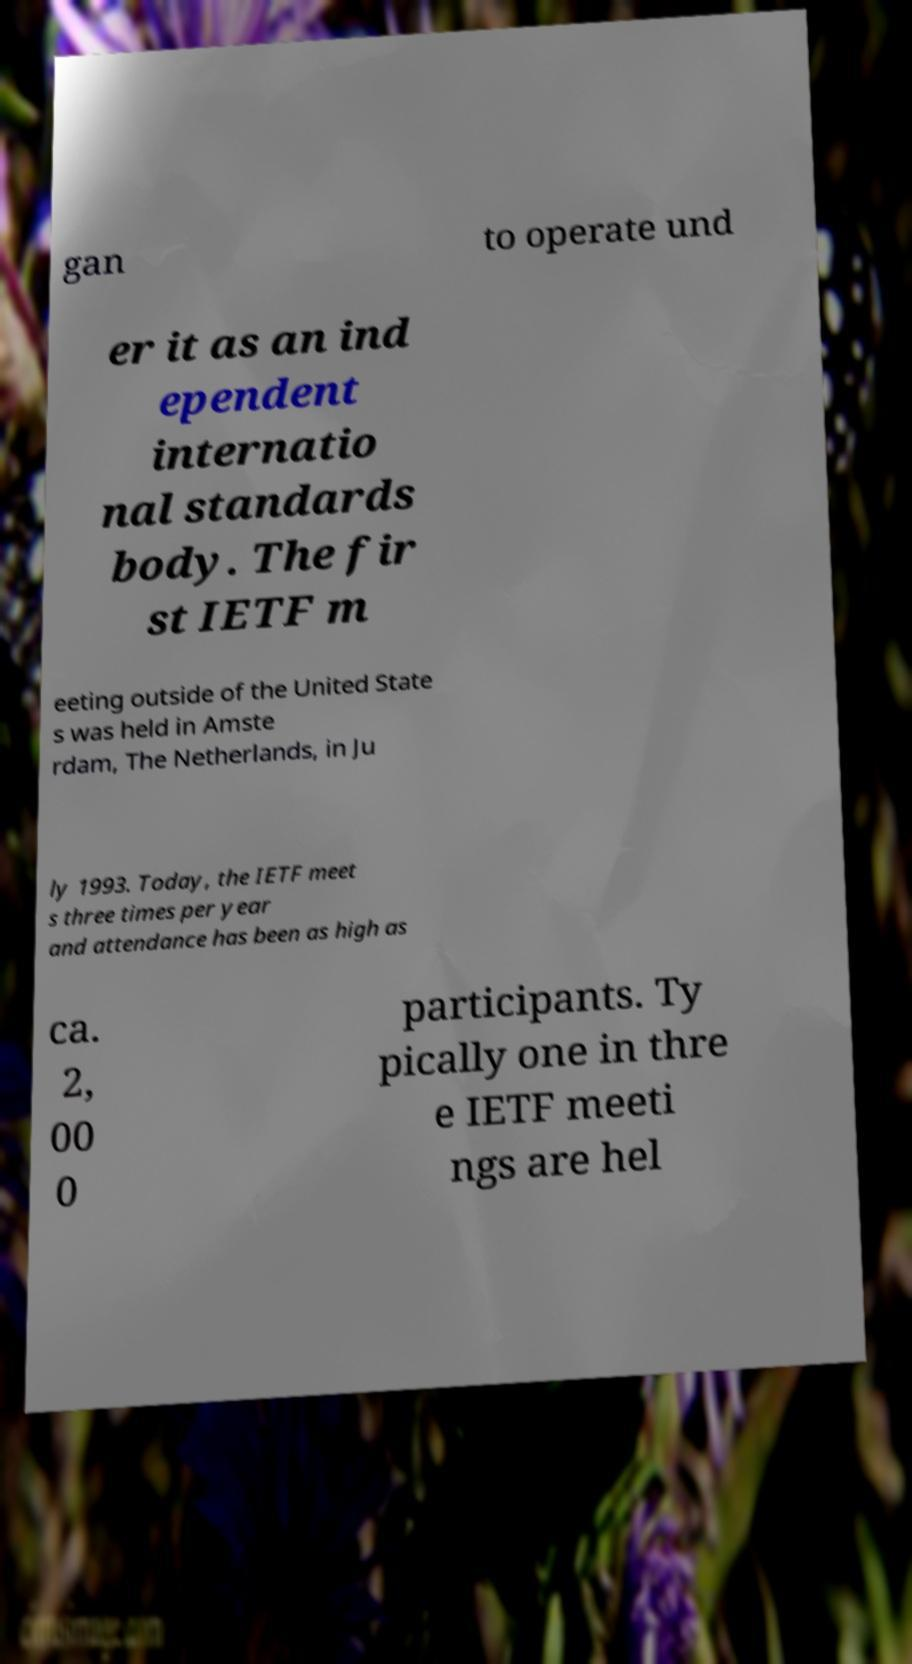Please read and relay the text visible in this image. What does it say? gan to operate und er it as an ind ependent internatio nal standards body. The fir st IETF m eeting outside of the United State s was held in Amste rdam, The Netherlands, in Ju ly 1993. Today, the IETF meet s three times per year and attendance has been as high as ca. 2, 00 0 participants. Ty pically one in thre e IETF meeti ngs are hel 